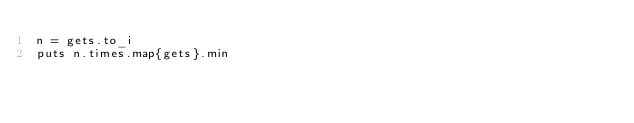Convert code to text. <code><loc_0><loc_0><loc_500><loc_500><_Ruby_>n = gets.to_i
puts n.times.map{gets}.min</code> 